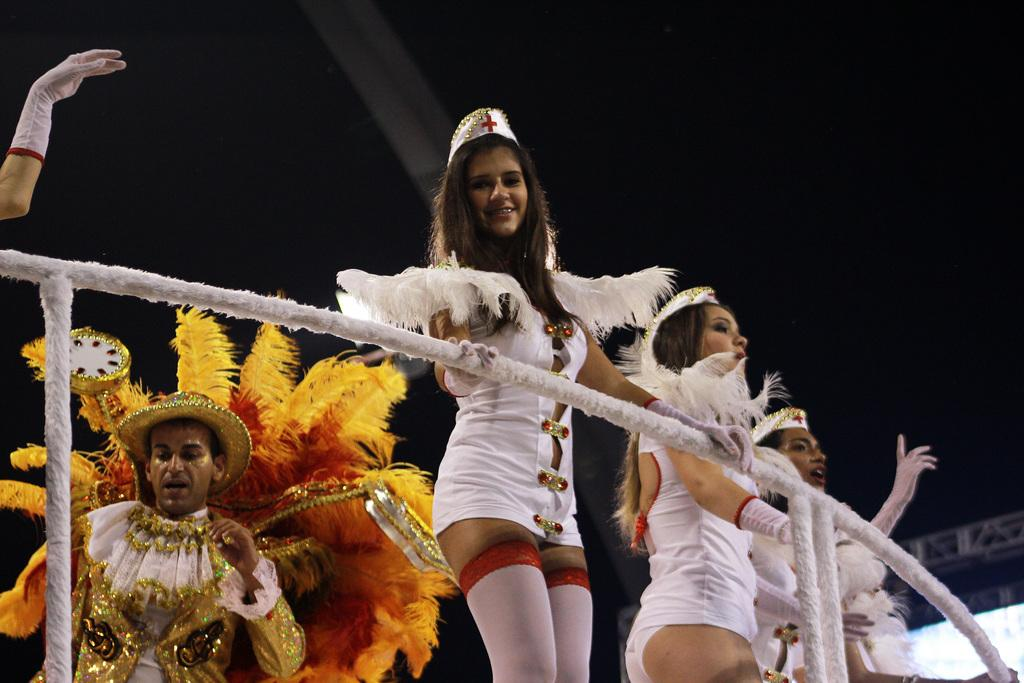What are the people in the image wearing? The people in the image are wearing costumes. What objects can be seen in the image besides the people? There are rods visible in the image. How would you describe the overall appearance of the image? The background of the image is dark. Can you see any goldfish swimming in the image? There are no goldfish present in the image. What is the moon's position in relation to the people in the image? There is no moon visible in the image. 